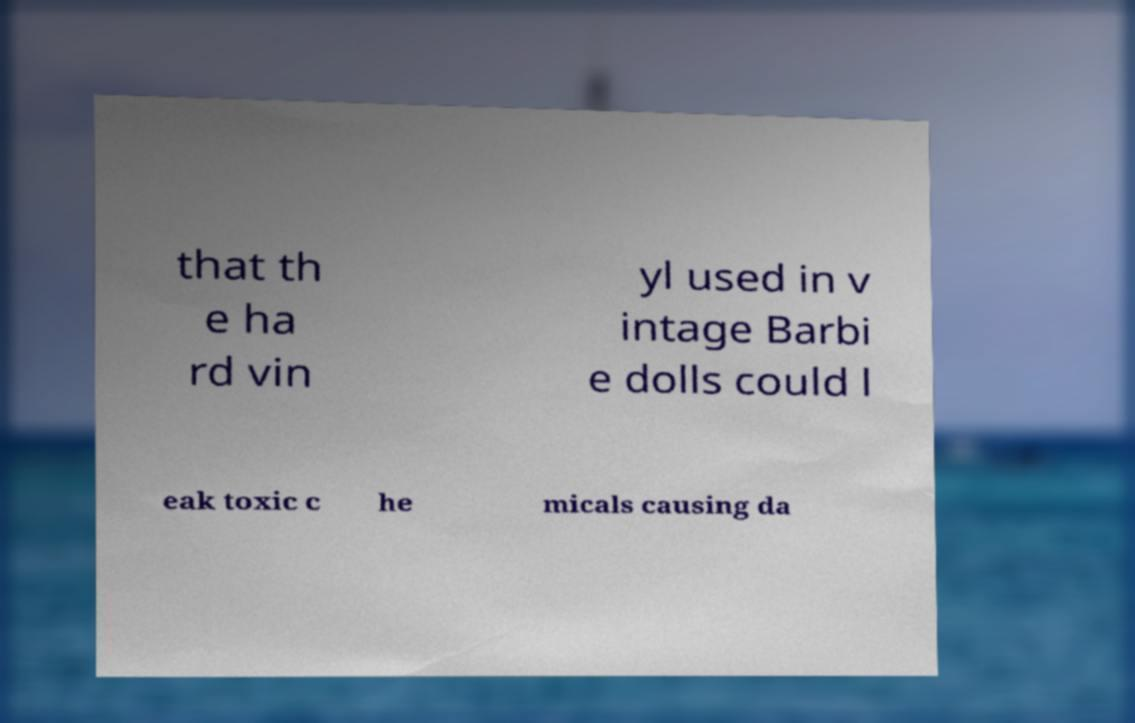Please identify and transcribe the text found in this image. that th e ha rd vin yl used in v intage Barbi e dolls could l eak toxic c he micals causing da 